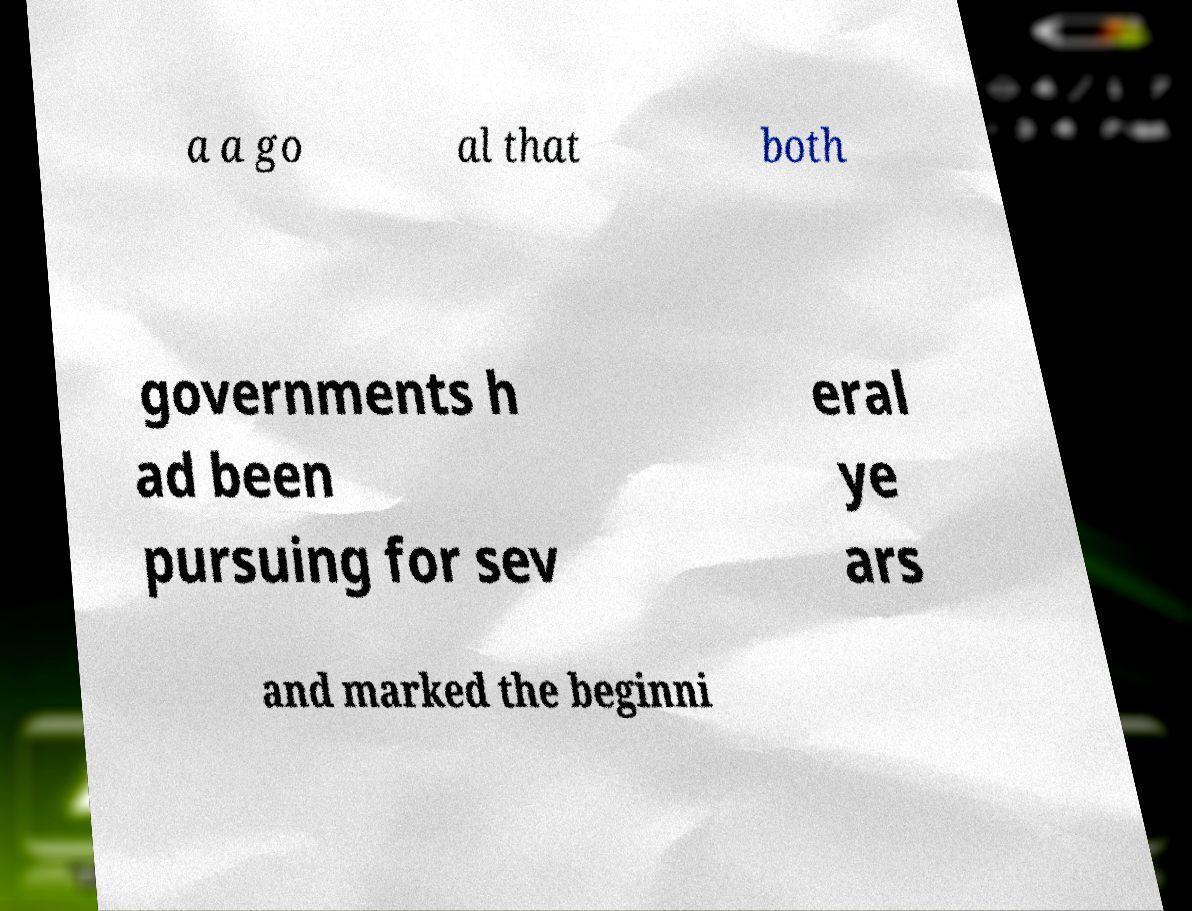Please identify and transcribe the text found in this image. a a go al that both governments h ad been pursuing for sev eral ye ars and marked the beginni 